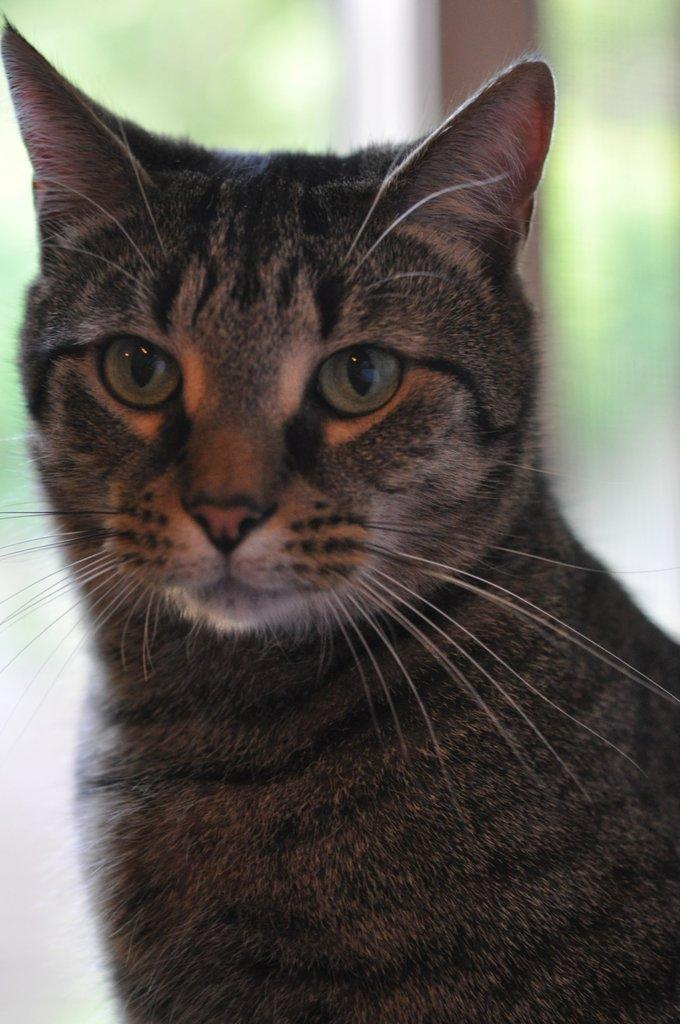What type of animal is in the image? There is a cat in the image. Can you describe the color of the cat? The cat is grey and brown in color. What can be observed about the background of the image? The background of the image is blurred. What type of breakfast is the cat eating in the image? There is no breakfast present in the image, as it features a cat and the focus is on the cat's color and the blurred background. 